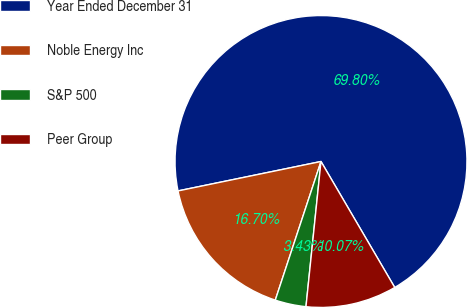<chart> <loc_0><loc_0><loc_500><loc_500><pie_chart><fcel>Year Ended December 31<fcel>Noble Energy Inc<fcel>S&P 500<fcel>Peer Group<nl><fcel>69.8%<fcel>16.7%<fcel>3.43%<fcel>10.07%<nl></chart> 